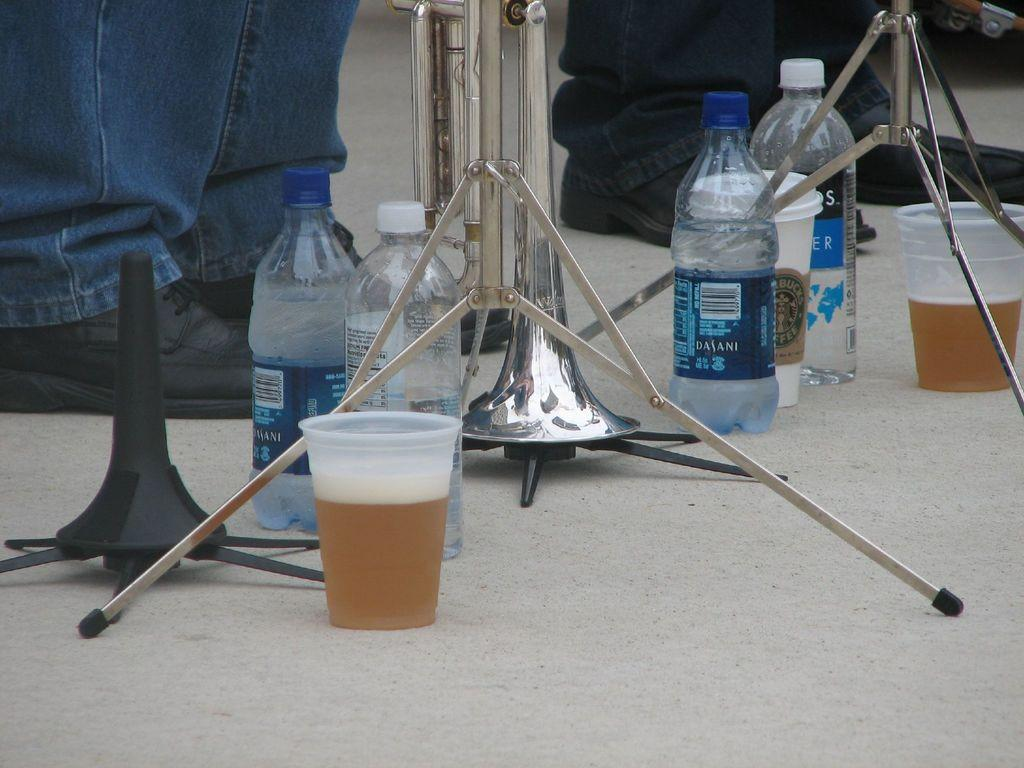<image>
Render a clear and concise summary of the photo. Multiple cups and bottles on the floor with a Dasani water bottle filled beside an emptier bottle. 